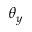<formula> <loc_0><loc_0><loc_500><loc_500>\theta _ { y }</formula> 